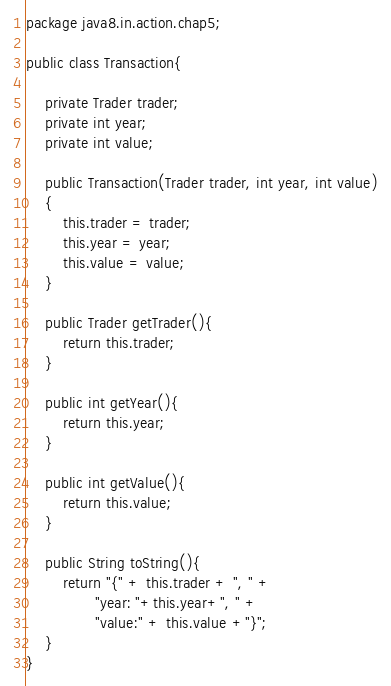<code> <loc_0><loc_0><loc_500><loc_500><_Java_>package java8.in.action.chap5;

public class Transaction{

	private Trader trader;
	private int year;
	private int value;

	public Transaction(Trader trader, int year, int value)
	{
		this.trader = trader;
		this.year = year;
		this.value = value;
	}

	public Trader getTrader(){ 
		return this.trader;
	}

	public int getYear(){
		return this.year;
	}

	public int getValue(){
		return this.value;
	}
	
	public String toString(){
	    return "{" + this.trader + ", " +
	           "year: "+this.year+", " +
	           "value:" + this.value +"}";
	}
}</code> 